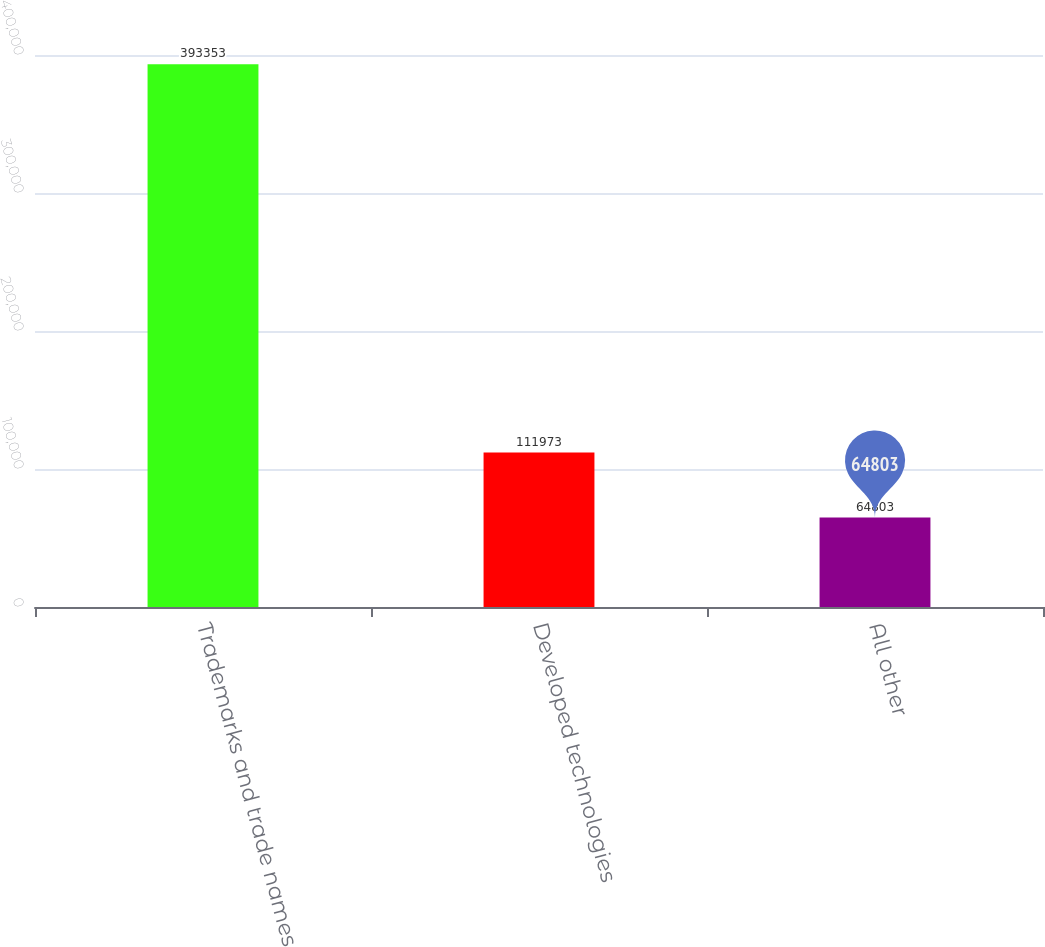Convert chart. <chart><loc_0><loc_0><loc_500><loc_500><bar_chart><fcel>Trademarks and trade names<fcel>Developed technologies<fcel>All other<nl><fcel>393353<fcel>111973<fcel>64803<nl></chart> 